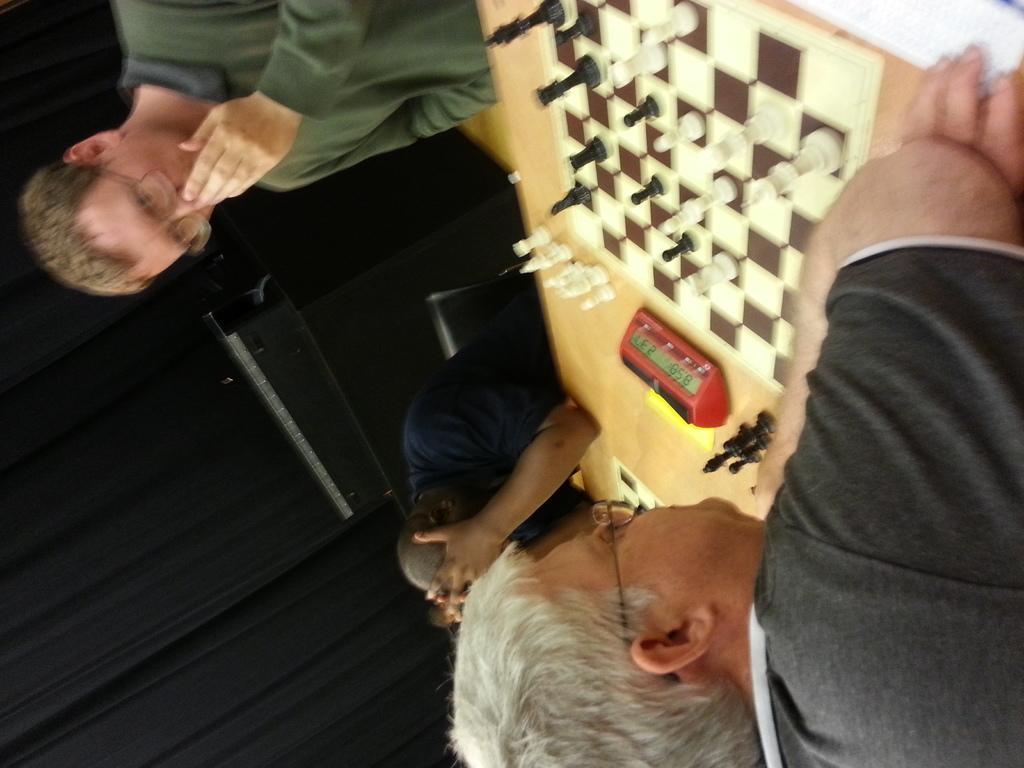Could you give a brief overview of what you see in this image? There are people sitting on chair and we can see chess boards, chess pieces and clock on the table. In the background we can see curtains and wall. 